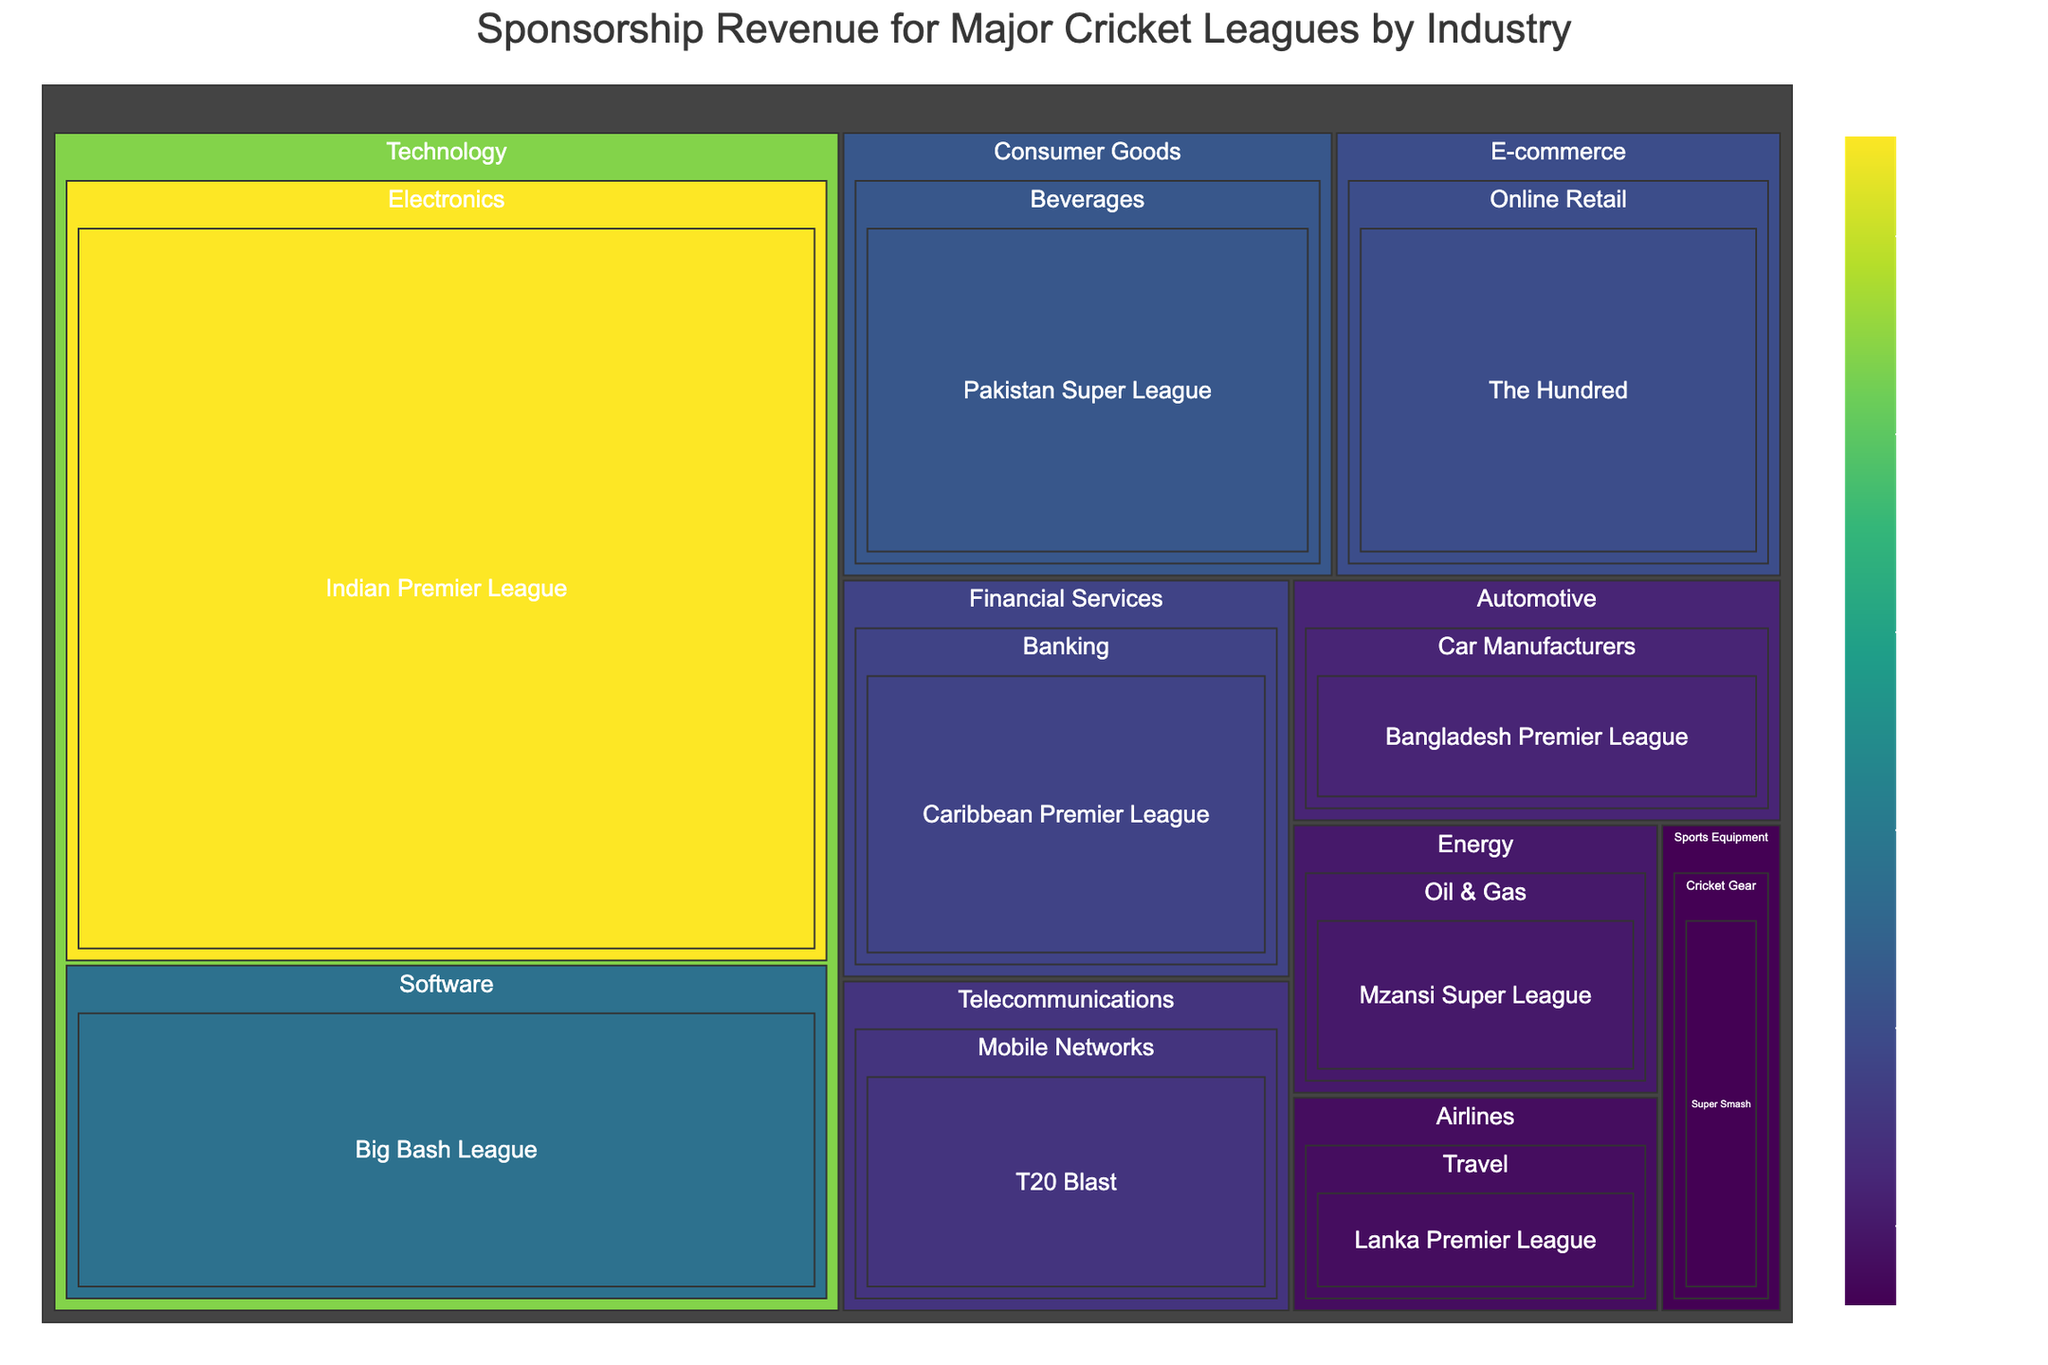What is the title of the treemap? The title of the treemap can be read at the top of the figure.
Answer: Sponsorship Revenue for Major Cricket Leagues by Industry How many industry sectors are represented in the treemap? Count the number of distinct industry categories shown in the treemap.
Answer: 10 Which league has the highest sponsorship revenue? Compare the revenue values of all leagues shown in the treemap and identify the highest value.
Answer: Indian Premier League How much total sponsorship revenue is generated by the Technology industry? Sum the revenue values for all leagues under the Technology industry category.
Answer: $93,000,000 Which sector within the Technology industry has the highest revenue? Compare the revenue values of the sectors within the Technology industry.
Answer: Electronics What is the sponsorship revenue for the Telecommunications sector? Locate the Telecommunications sector and note the revenue value displayed.
Answer: $15,000,000 Which league has greater sponsorship revenue, the Caribbean Premier League or the The Hundred? Compare the revenue figures of the Caribbean Premier League and The Hundred.
Answer: The Hundred How does the revenue of the Pakistan Super League compare to that of the Big Bash League? Compare the revenue values of the Pakistan Super League and the Big Bash League.
Answer: The Big Bash League has higher revenue If the sponsorship revenues of the Lankan Premier League and the Super Smash are combined, what is the total? Sum the revenue values of the Lankan Premier League and the Super Smash.
Answer: $14,000,000 Which industry has the least contribution to the sponsorship revenue of the Major Cricket Leagues? Identify the industry with the smallest total revenue value.
Answer: Sports Equipment 